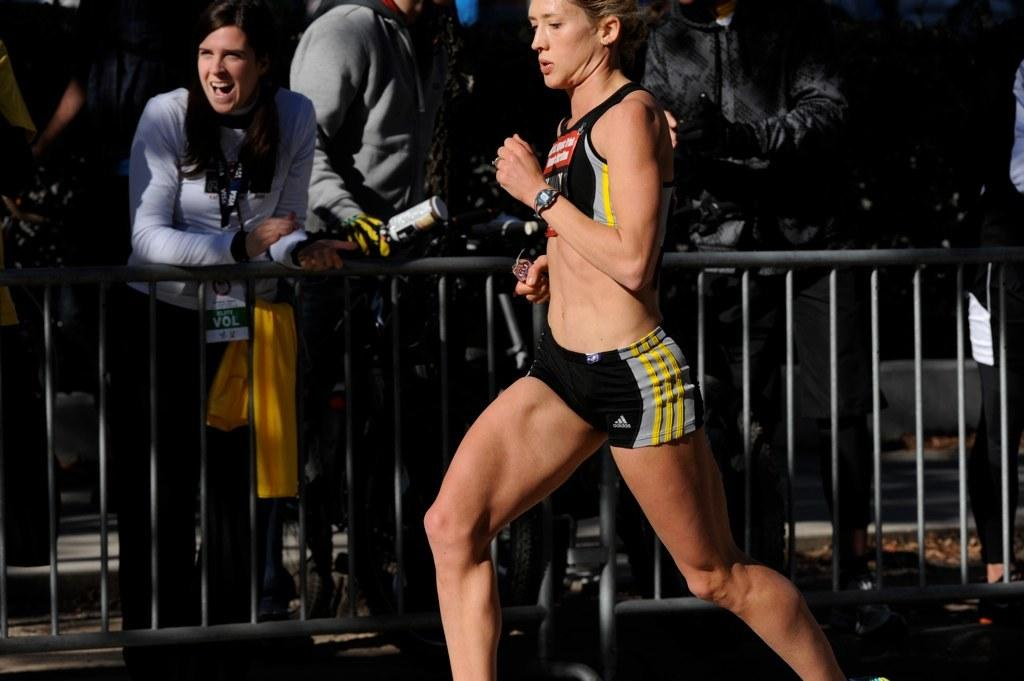What is the lady in the image doing? The lady is running in the image. What can be seen in the background of the image? There are people standing in the background of the image. What is the purpose of the fencing in the image? The purpose of the fencing in the image is not explicitly stated, but it could be for safety or to mark boundaries. What type of pizzas can be seen in the image? There are no pizzas present in the image. 